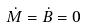Convert formula to latex. <formula><loc_0><loc_0><loc_500><loc_500>\dot { M } = \dot { B } = 0</formula> 